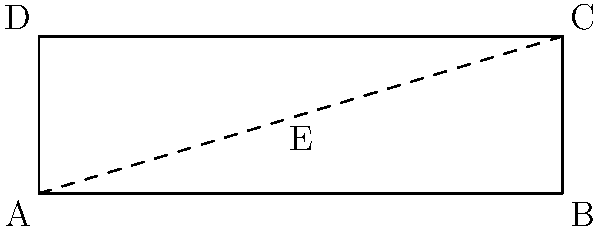A rectangular quarantine area for infected swine measures 30m by 9m. The drainage system requires a 5% slope from both the north and south edges towards a central drain line. Calculate the height difference (in meters) between the edges and the central drain line. To solve this problem, we'll follow these steps:

1. Understand the given information:
   - The quarantine area is 30m long and 9m wide
   - The slope is 5% from both north and south edges towards the center

2. Calculate the width of each sloped section:
   - Total width = 9m
   - Each section = 9m ÷ 2 = 4.5m

3. Calculate the height difference using the slope formula:
   - Slope = Rise ÷ Run
   - 5% = 0.05 = Rise ÷ 4.5m
   - Rise = 0.05 × 4.5m = 0.225m

4. Convert the result to meters:
   - Height difference = 0.225m

Therefore, the height difference between the edges and the central drain line is 0.225 meters.
Answer: 0.225m 